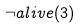Convert formula to latex. <formula><loc_0><loc_0><loc_500><loc_500>\neg a l i v e ( 3 )</formula> 